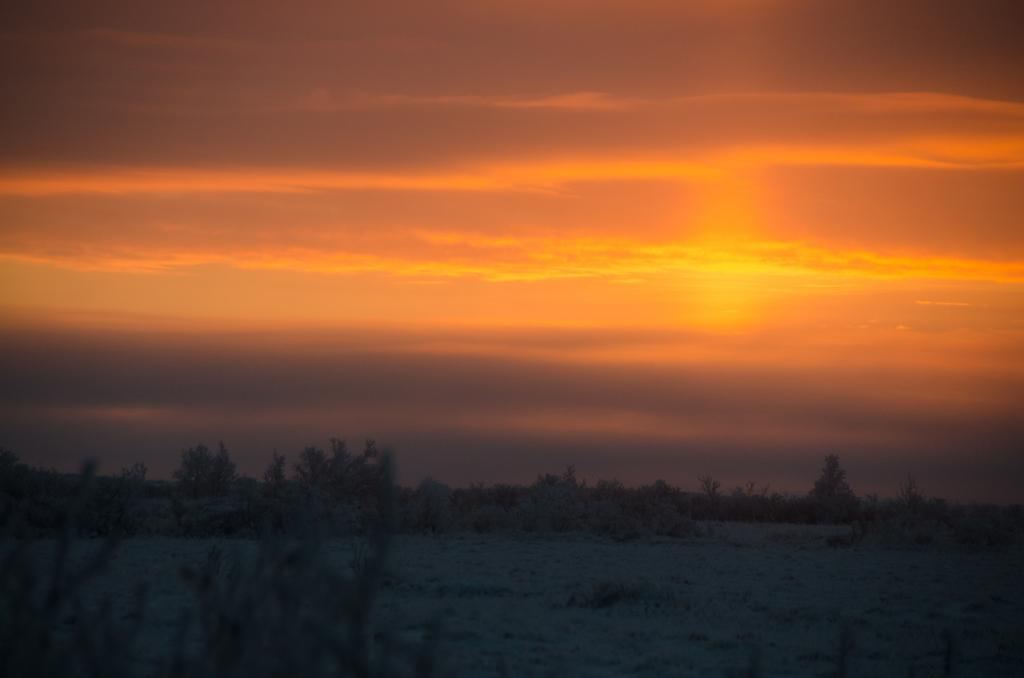What type of living organisms can be seen in the image? Plants can be seen in the image. What is visible in the background of the image? The sky is red in the background of the image. Can you tell me where the club is located in the image? There is no club present in the image; it only features plants and a red sky. 